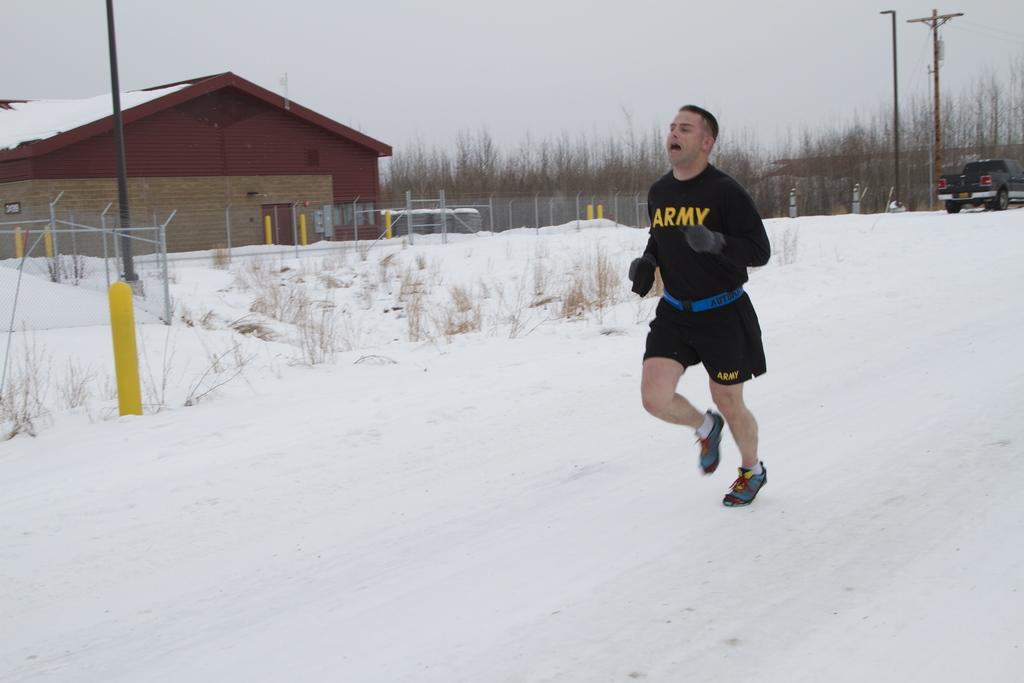What branch of the military is one the man's shirt?
Provide a succinct answer. Army. What does the man's shirt say?
Provide a succinct answer. Army. 